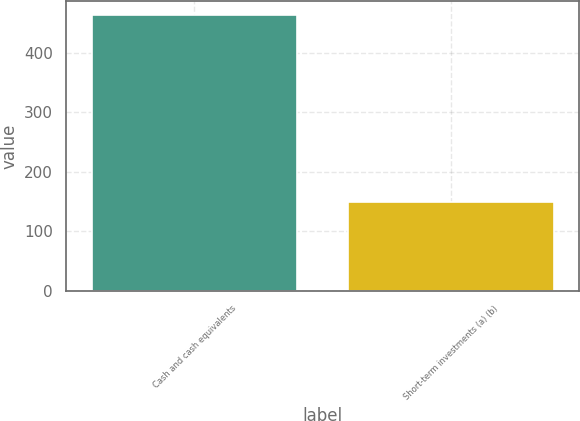Convert chart. <chart><loc_0><loc_0><loc_500><loc_500><bar_chart><fcel>Cash and cash equivalents<fcel>Short-term investments (a) (b)<nl><fcel>464<fcel>150<nl></chart> 